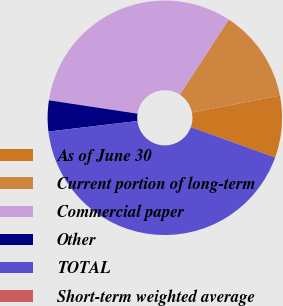Convert chart to OTSL. <chart><loc_0><loc_0><loc_500><loc_500><pie_chart><fcel>As of June 30<fcel>Current portion of long-term<fcel>Commercial paper<fcel>Other<fcel>TOTAL<fcel>Short-term weighted average<nl><fcel>8.53%<fcel>12.79%<fcel>31.79%<fcel>4.26%<fcel>42.63%<fcel>0.0%<nl></chart> 